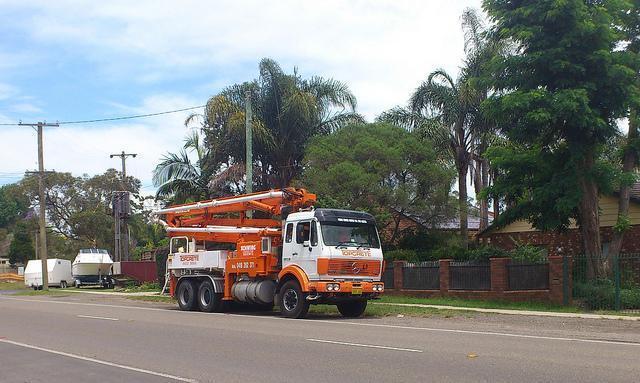How many orange cones are there?
Give a very brief answer. 0. 